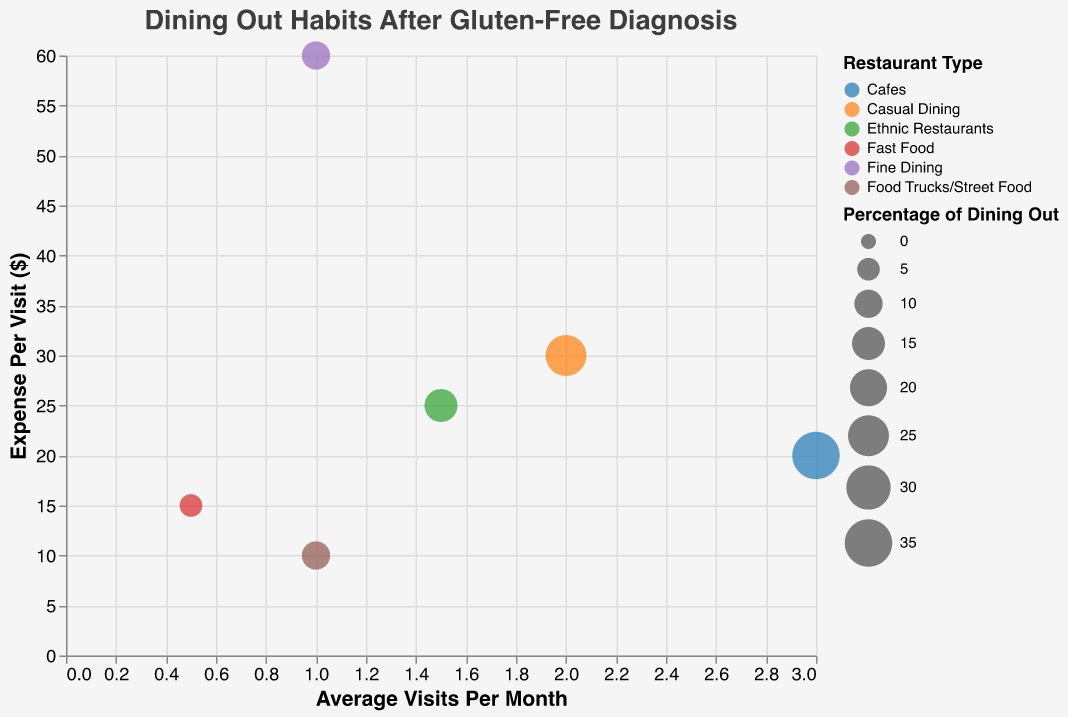What is the title of the chart? The title is written at the top of the chart in a larger font size.
Answer: Dining Out Habits After Gluten-Free Diagnosis How many types of restaurants are represented in the chart? There are colored bubbles on the chart, each representing a different restaurant type.
Answer: 6 Which restaurant type has the highest average visits per month? Look at the x-axis (Average Visits Per Month) and find the bubble with the highest x value.
Answer: Cafes Which restaurant type has the lowest expense per visit? Examine the y-axis (Expense Per Visit) and locate the bubble lowest on the y-axis.
Answer: Food Trucks/Street Food What is the expense per visit for Casual Dining compared to Ethnic Restaurants? Check the y-axis values for both Casual Dining and Ethnic Restaurants (Casual Dining is $30, Ethnic Restaurants is $25).
Answer: Casual Dining has a higher expense per visit Which restaurant type has the largest percentage of dining out? Compare the sizes of the bubbles; the largest bubble represents the highest percentage.
Answer: Cafes Is the percentage of dining out at Food Trucks/Street Food greater than that at Fine Dining? Check the size of the bubbles for both Food Trucks/Street Food and Fine Dining to compare their percentages.
Answer: No, they both have 10% How does the expense per visit for Fine Dining compare to Casual Dining? Look at the y-axis values for both Fine Dining ($60) and Casual Dining ($30) to compare.
Answer: Fine Dining has a higher expense per visit What is the average expense per visit across all restaurant types? Calculate the mean expense per visit using the given values: (60 + 30 + 15 + 20 + 10 + 25) / 6 = 26.67.
Answer: $26.67 Which restaurant has the highest combination of average visits per month and expense per visit? Compare bubbles for both high x (Average Visits Per Month) and high y (Expense Per Visit) values.
Answer: Cafes 